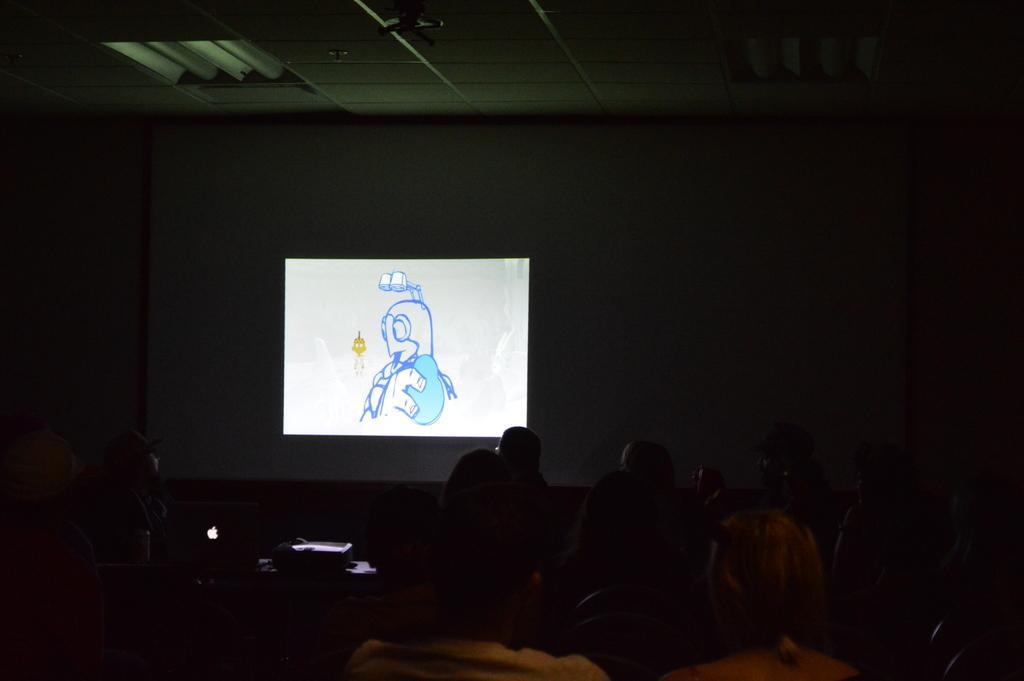In one or two sentences, can you explain what this image depicts? In this image I can see the group of people. In-front of these people I can see the screen and there is a ceiling in the top. 